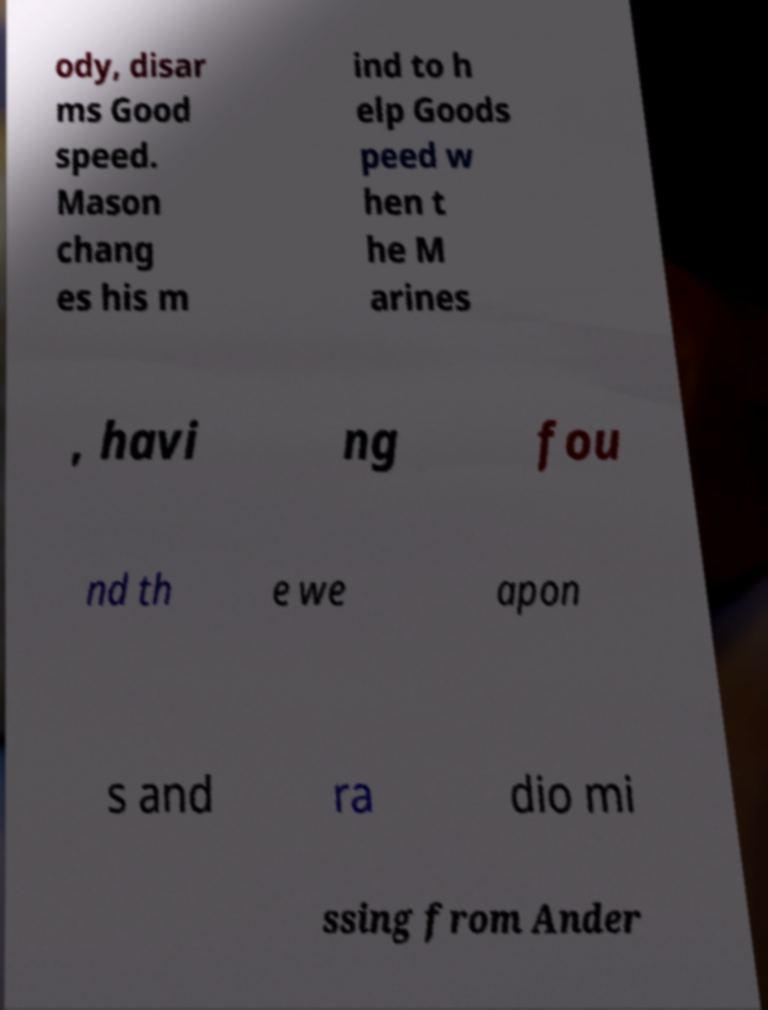Could you extract and type out the text from this image? ody, disar ms Good speed. Mason chang es his m ind to h elp Goods peed w hen t he M arines , havi ng fou nd th e we apon s and ra dio mi ssing from Ander 